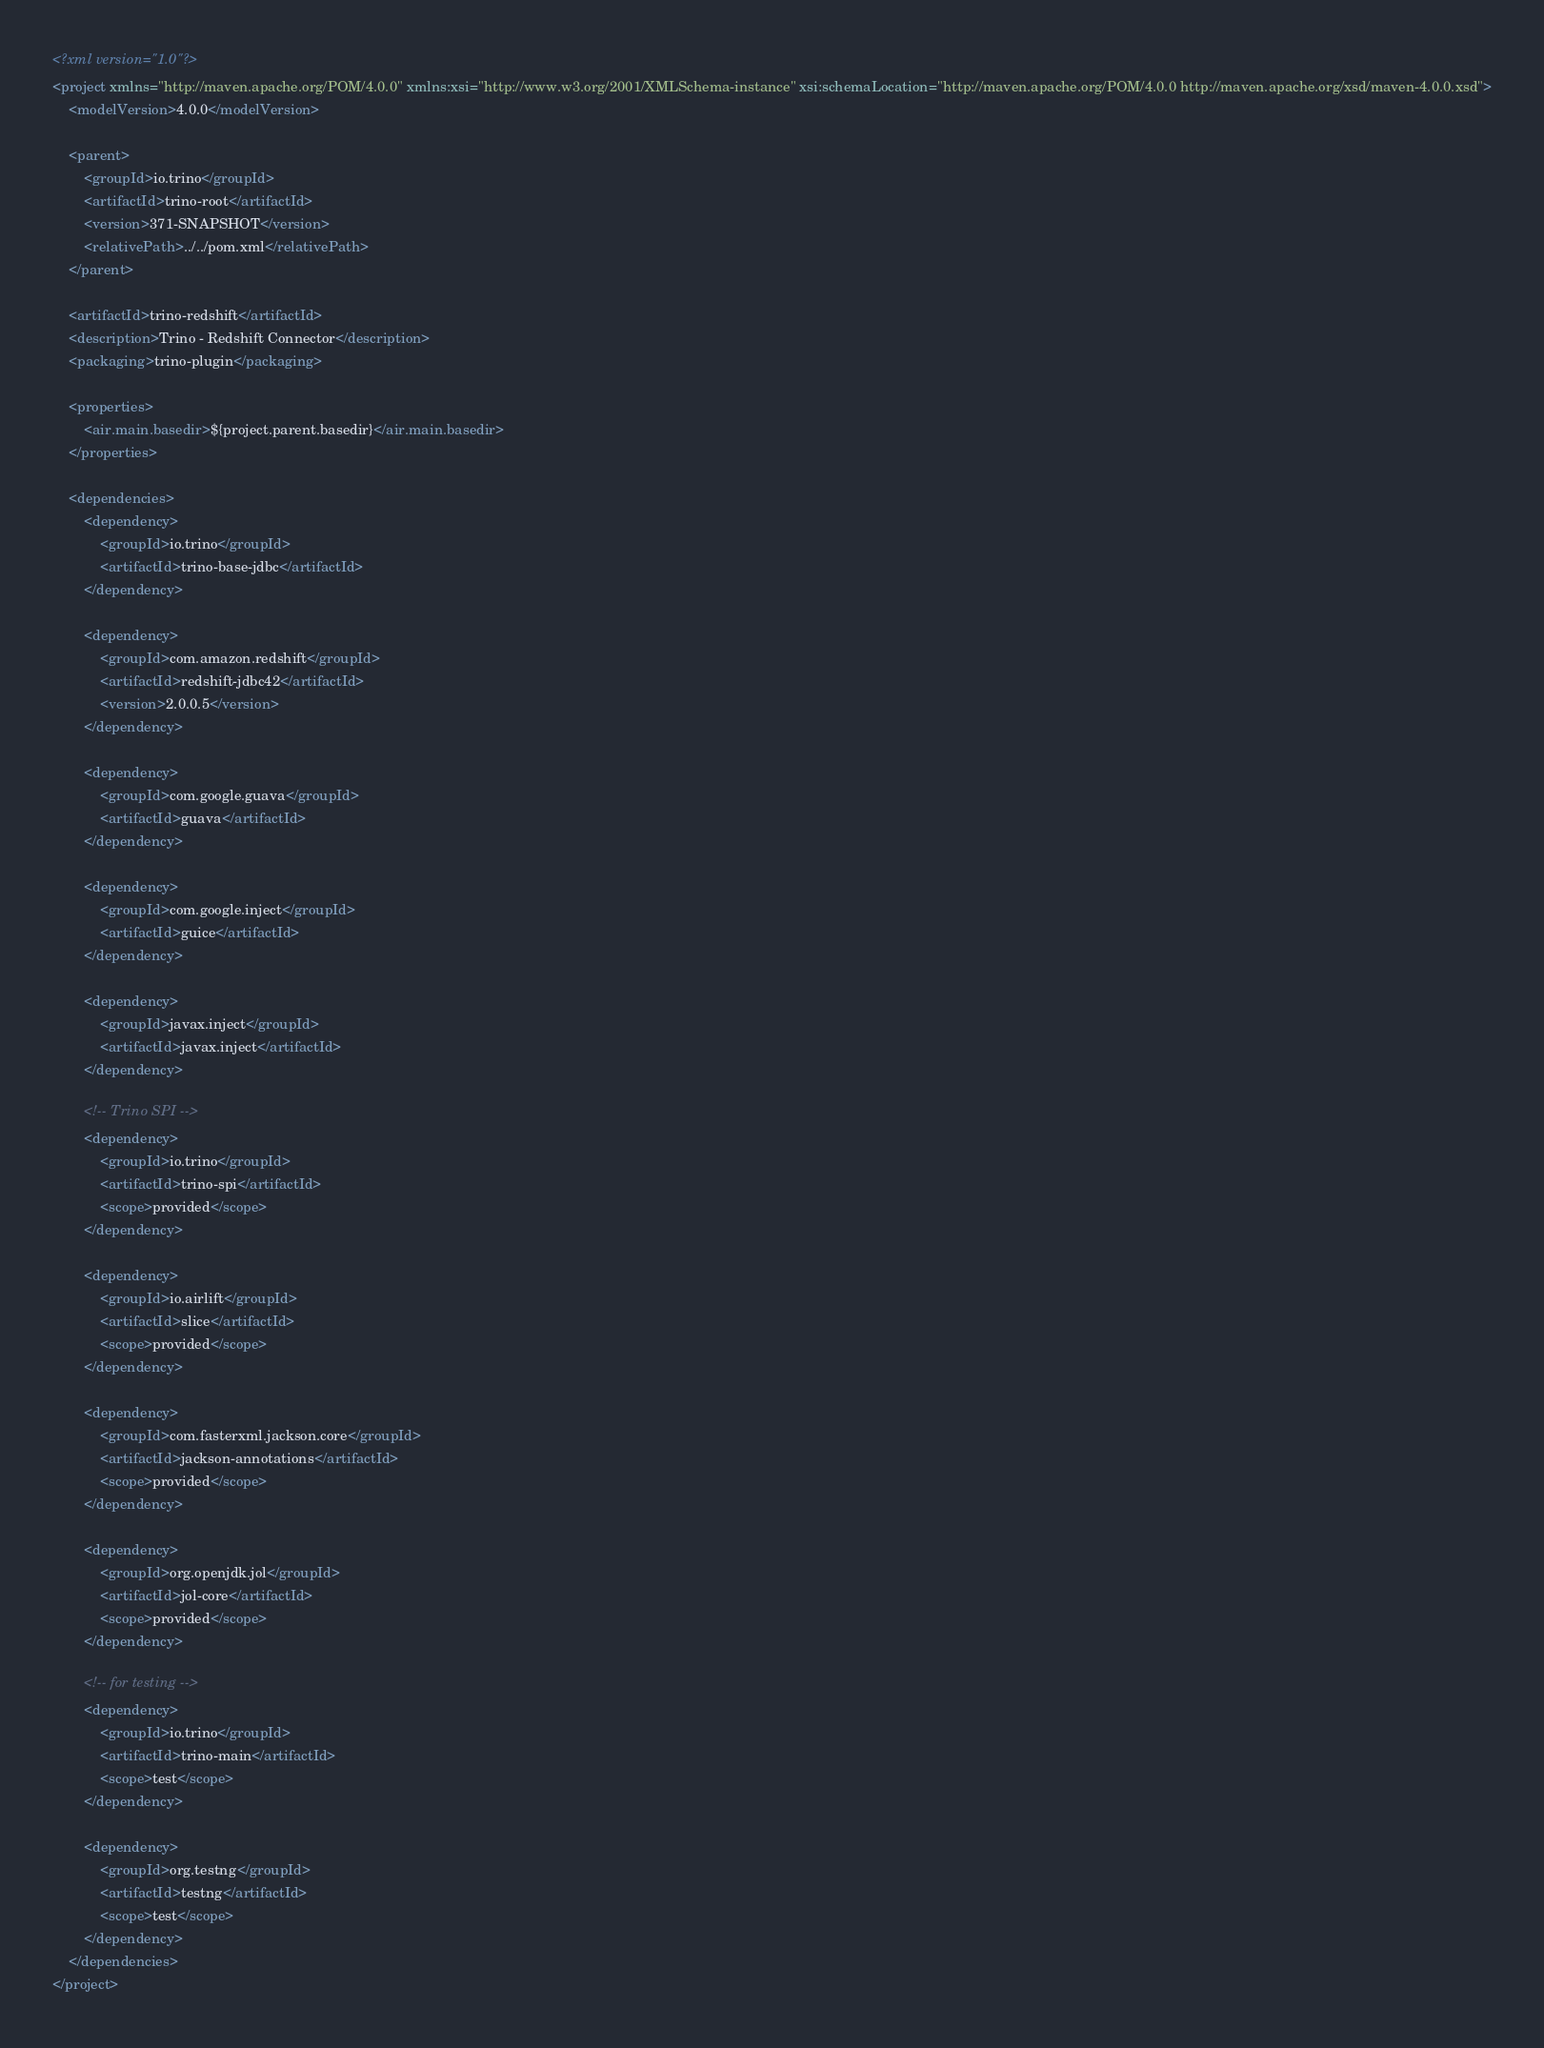Convert code to text. <code><loc_0><loc_0><loc_500><loc_500><_XML_><?xml version="1.0"?>
<project xmlns="http://maven.apache.org/POM/4.0.0" xmlns:xsi="http://www.w3.org/2001/XMLSchema-instance" xsi:schemaLocation="http://maven.apache.org/POM/4.0.0 http://maven.apache.org/xsd/maven-4.0.0.xsd">
    <modelVersion>4.0.0</modelVersion>

    <parent>
        <groupId>io.trino</groupId>
        <artifactId>trino-root</artifactId>
        <version>371-SNAPSHOT</version>
        <relativePath>../../pom.xml</relativePath>
    </parent>

    <artifactId>trino-redshift</artifactId>
    <description>Trino - Redshift Connector</description>
    <packaging>trino-plugin</packaging>

    <properties>
        <air.main.basedir>${project.parent.basedir}</air.main.basedir>
    </properties>

    <dependencies>
        <dependency>
            <groupId>io.trino</groupId>
            <artifactId>trino-base-jdbc</artifactId>
        </dependency>

        <dependency>
            <groupId>com.amazon.redshift</groupId>
            <artifactId>redshift-jdbc42</artifactId>
            <version>2.0.0.5</version>
        </dependency>

        <dependency>
            <groupId>com.google.guava</groupId>
            <artifactId>guava</artifactId>
        </dependency>

        <dependency>
            <groupId>com.google.inject</groupId>
            <artifactId>guice</artifactId>
        </dependency>

        <dependency>
            <groupId>javax.inject</groupId>
            <artifactId>javax.inject</artifactId>
        </dependency>

        <!-- Trino SPI -->
        <dependency>
            <groupId>io.trino</groupId>
            <artifactId>trino-spi</artifactId>
            <scope>provided</scope>
        </dependency>

        <dependency>
            <groupId>io.airlift</groupId>
            <artifactId>slice</artifactId>
            <scope>provided</scope>
        </dependency>

        <dependency>
            <groupId>com.fasterxml.jackson.core</groupId>
            <artifactId>jackson-annotations</artifactId>
            <scope>provided</scope>
        </dependency>

        <dependency>
            <groupId>org.openjdk.jol</groupId>
            <artifactId>jol-core</artifactId>
            <scope>provided</scope>
        </dependency>

        <!-- for testing -->
        <dependency>
            <groupId>io.trino</groupId>
            <artifactId>trino-main</artifactId>
            <scope>test</scope>
        </dependency>

        <dependency>
            <groupId>org.testng</groupId>
            <artifactId>testng</artifactId>
            <scope>test</scope>
        </dependency>
    </dependencies>
</project>
</code> 